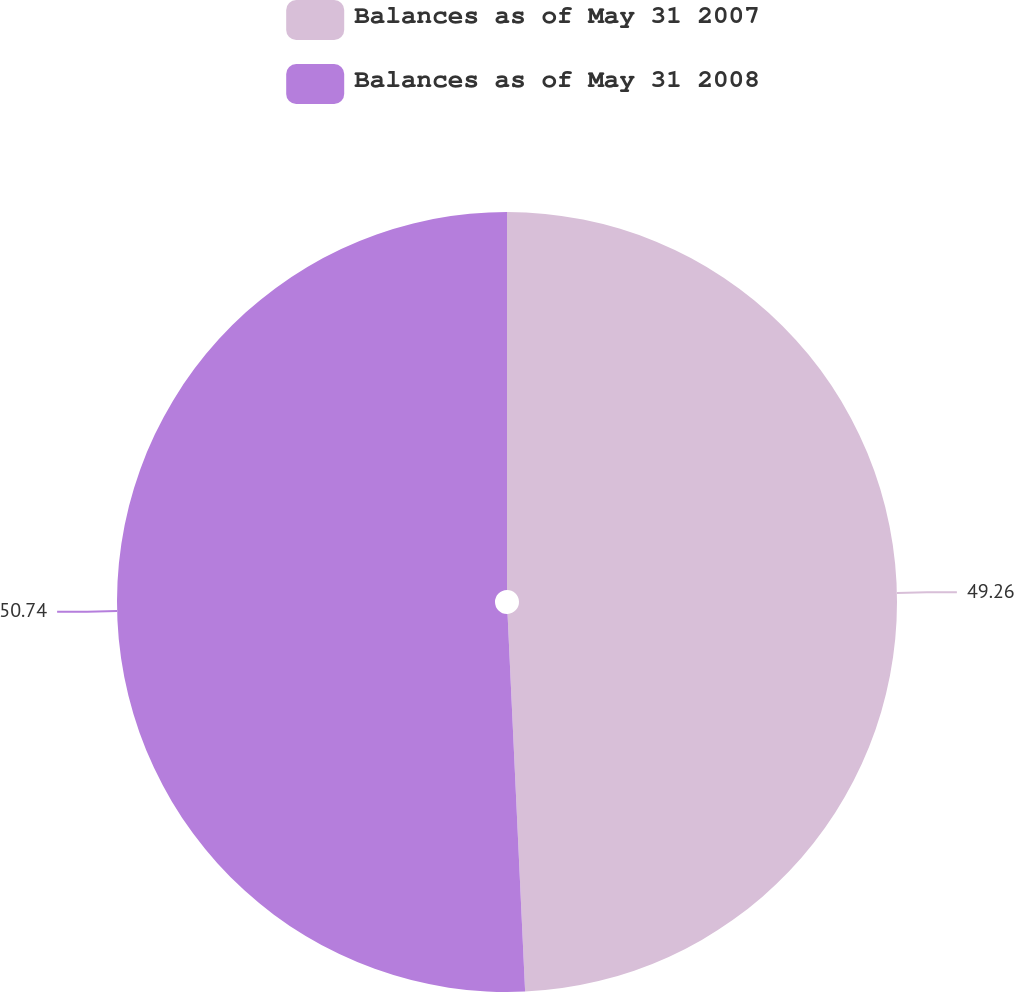Convert chart. <chart><loc_0><loc_0><loc_500><loc_500><pie_chart><fcel>Balances as of May 31 2007<fcel>Balances as of May 31 2008<nl><fcel>49.26%<fcel>50.74%<nl></chart> 